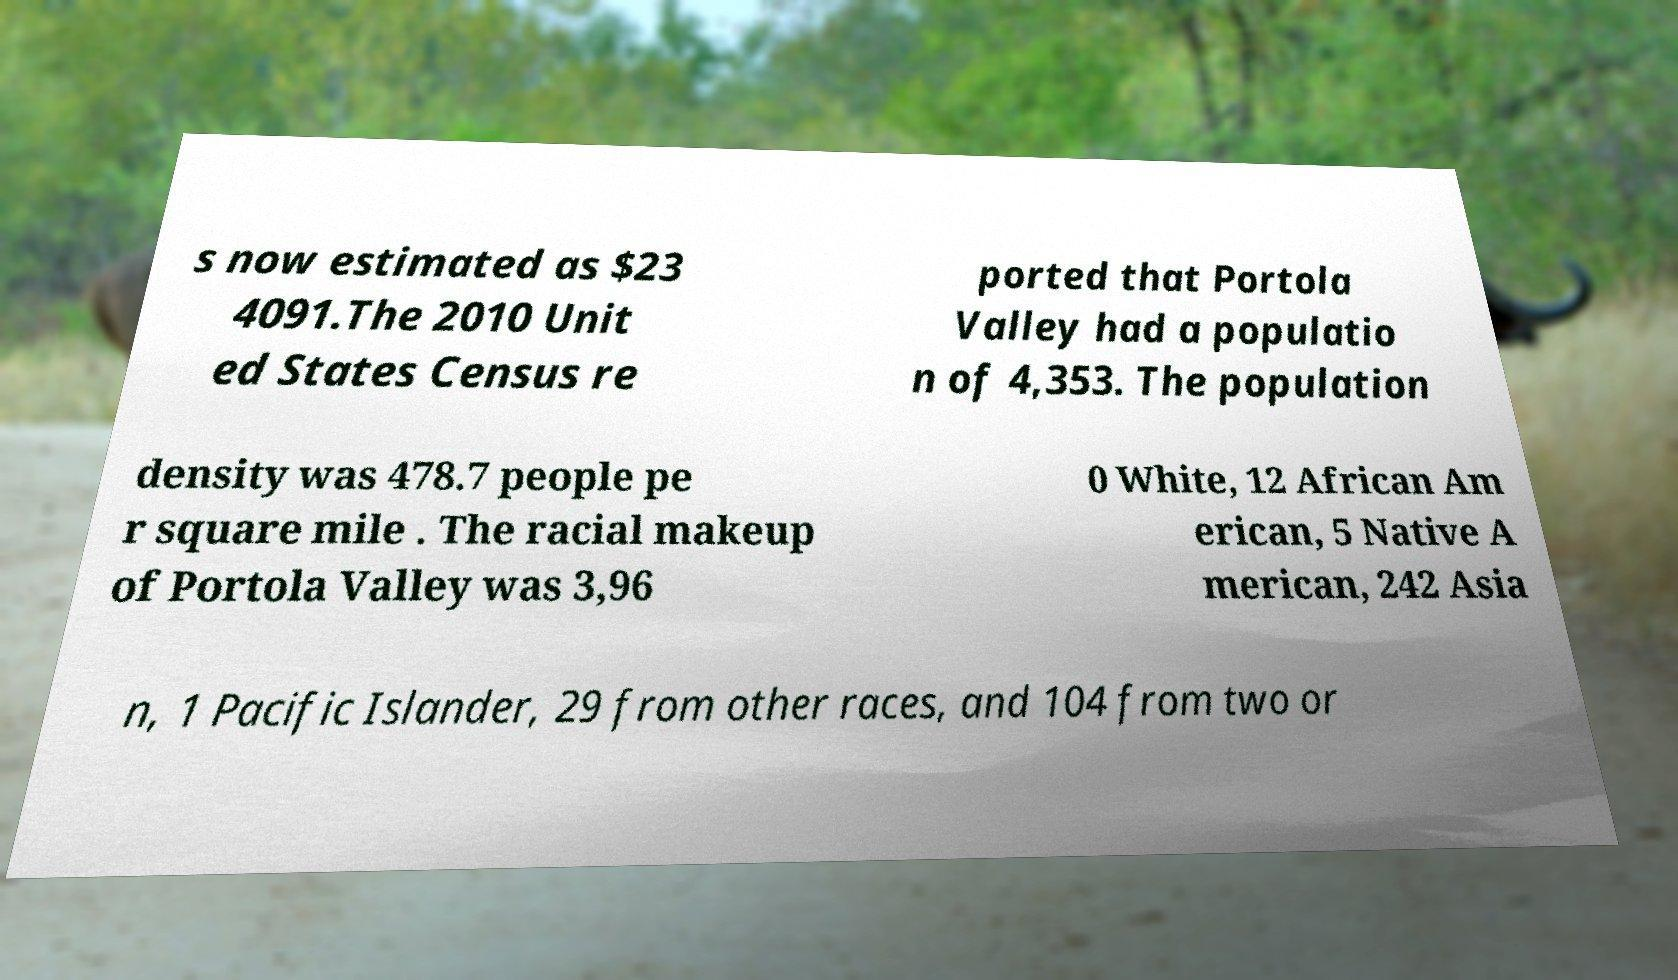Could you assist in decoding the text presented in this image and type it out clearly? s now estimated as $23 4091.The 2010 Unit ed States Census re ported that Portola Valley had a populatio n of 4,353. The population density was 478.7 people pe r square mile . The racial makeup of Portola Valley was 3,96 0 White, 12 African Am erican, 5 Native A merican, 242 Asia n, 1 Pacific Islander, 29 from other races, and 104 from two or 